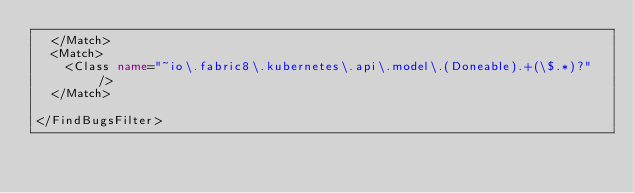<code> <loc_0><loc_0><loc_500><loc_500><_XML_>  </Match>
  <Match>
    <Class name="~io\.fabric8\.kubernetes\.api\.model\.(Doneable).+(\$.*)?" />
  </Match>

</FindBugsFilter></code> 